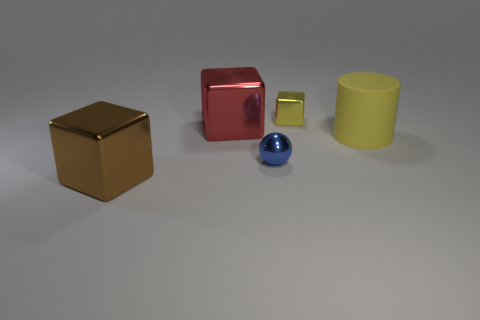Add 1 blue objects. How many objects exist? 6 Subtract all blocks. How many objects are left? 2 Subtract 0 cyan cylinders. How many objects are left? 5 Subtract all matte objects. Subtract all small yellow metal things. How many objects are left? 3 Add 4 big red objects. How many big red objects are left? 5 Add 3 tiny yellow objects. How many tiny yellow objects exist? 4 